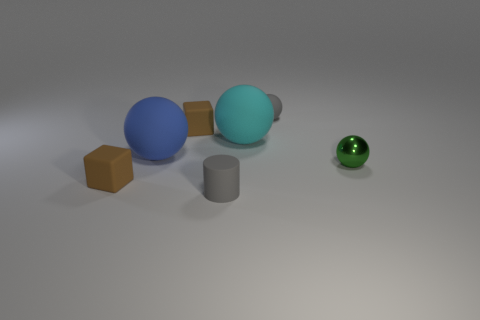How many tiny objects have the same color as the small rubber cylinder?
Ensure brevity in your answer.  1. Is there anything else that is the same shape as the small green thing?
Your response must be concise. Yes. Are there any small gray objects behind the gray object that is right of the gray object that is to the left of the small gray matte ball?
Provide a succinct answer. No. What number of other tiny cylinders have the same material as the gray cylinder?
Ensure brevity in your answer.  0. Is the size of the matte cube that is behind the metallic object the same as the rubber sphere right of the cyan thing?
Give a very brief answer. Yes. There is a matte thing that is on the left side of the matte sphere left of the rubber block that is on the right side of the blue matte ball; what is its color?
Provide a short and direct response. Brown. Is there another big brown metal object of the same shape as the shiny object?
Your answer should be very brief. No. Is the number of small brown matte things behind the small metallic thing the same as the number of tiny matte blocks that are on the left side of the large blue thing?
Provide a succinct answer. Yes. Does the big thing on the left side of the gray cylinder have the same shape as the large cyan matte thing?
Provide a short and direct response. Yes. Is the green object the same shape as the large blue thing?
Make the answer very short. Yes. 